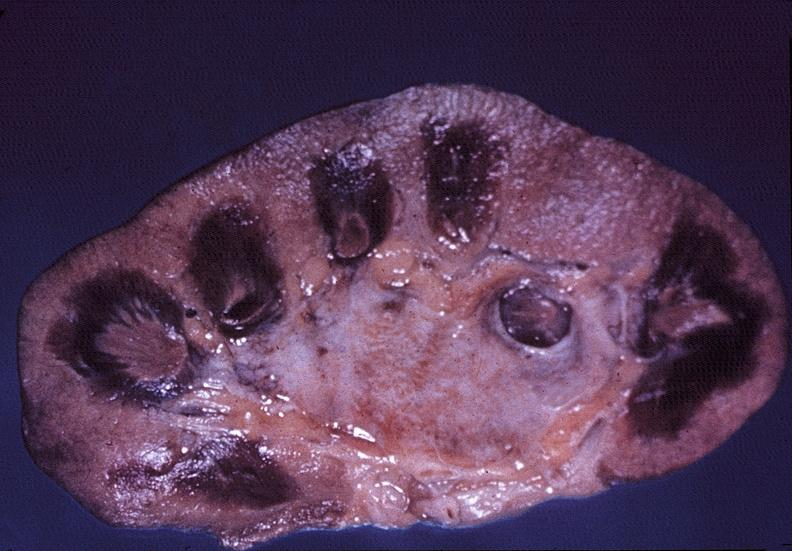what does this image show?
Answer the question using a single word or phrase. Kidney 